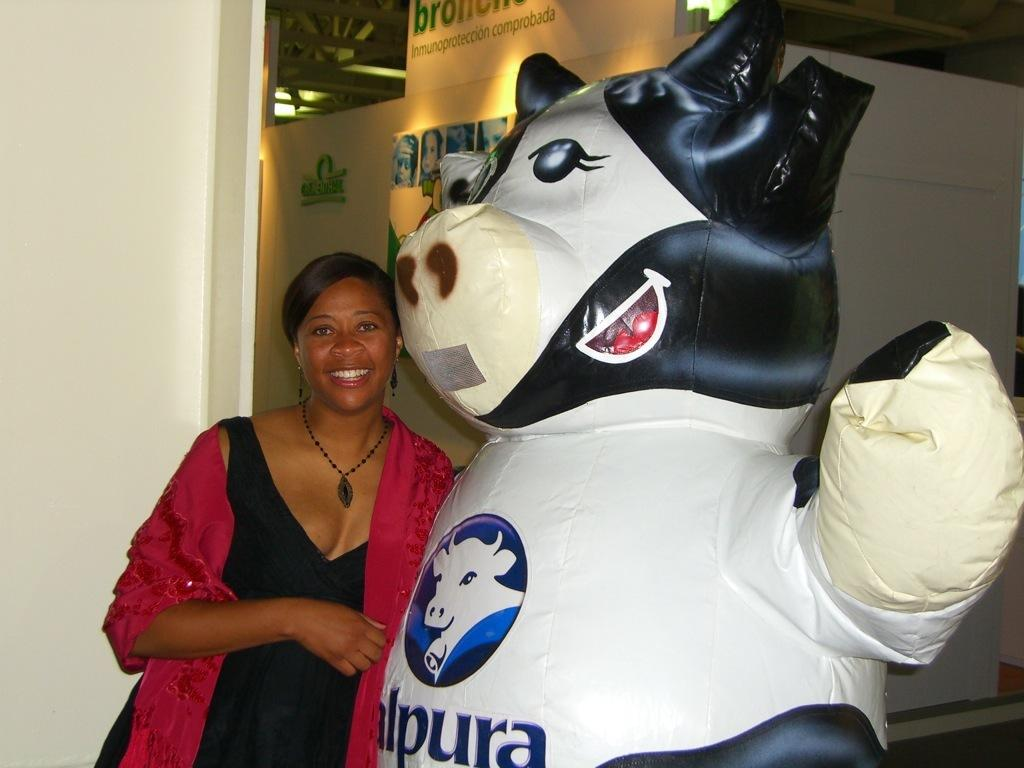<image>
Describe the image concisely. A woman in a dress standing near an inflated cow wearing a shirt with the letter p on it. 